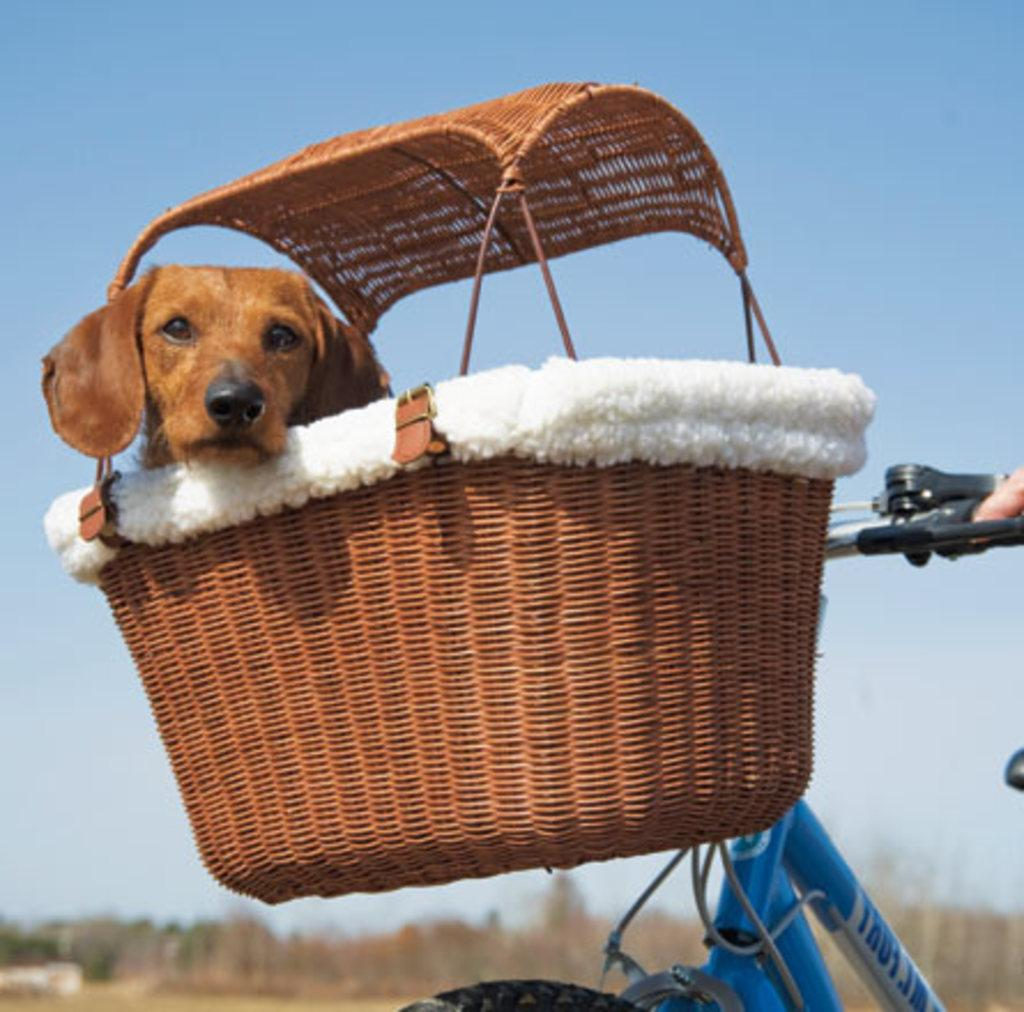What is the main subject of the image? There is a dog in a basket in the image. How is the basket positioned in relation to the bicycle? The basket is attached to a bicycle. What can be seen in the background of the image? The background of the image is blurred. What is visible at the top of the image? The sky is visible at the top of the image. How many kittens are playing in the yard in the image? There are no kittens or yards present in the image; it features a dog in a basket attached to a bicycle. 